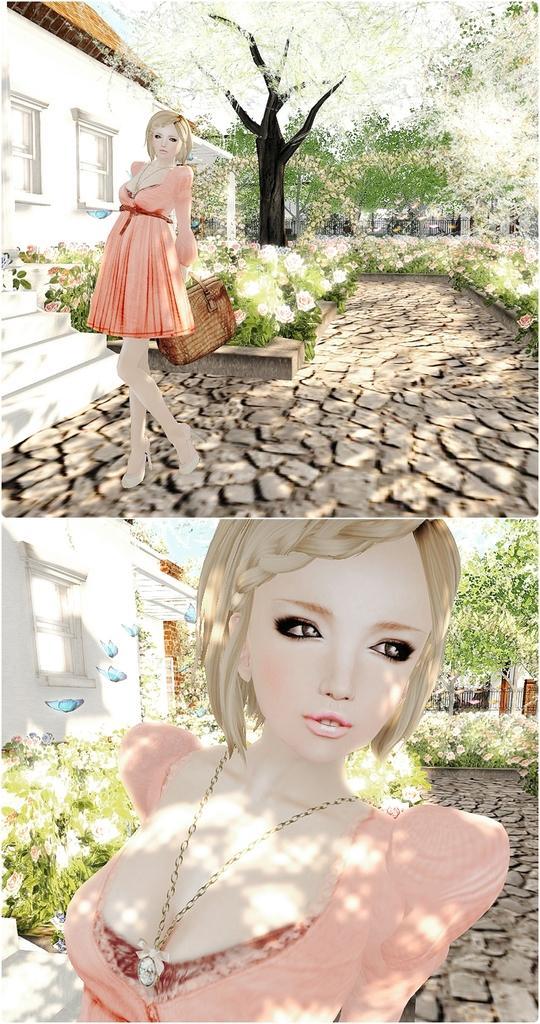Could you give a brief overview of what you see in this image? This is an animated collage image, there is a person standing and holding a bag, there are trees, there are plants, there are staircase, there are windows, there is a house truncated towards the left of the image, there are butterflies, there is a person truncated. 